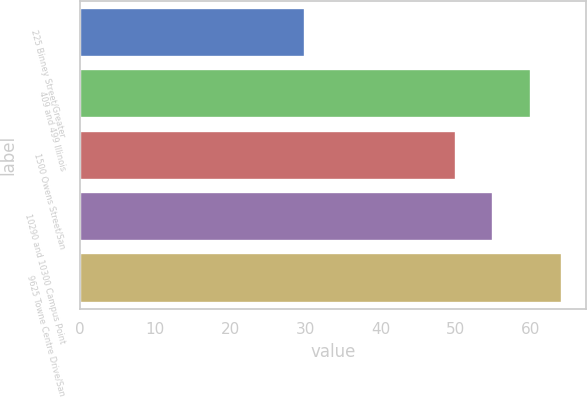Convert chart. <chart><loc_0><loc_0><loc_500><loc_500><bar_chart><fcel>225 Binney Street/Greater<fcel>409 and 499 Illinois<fcel>1500 Owens Street/San<fcel>10290 and 10300 Campus Point<fcel>9625 Towne Centre Drive/San<nl><fcel>30<fcel>60<fcel>50.1<fcel>55<fcel>64.1<nl></chart> 